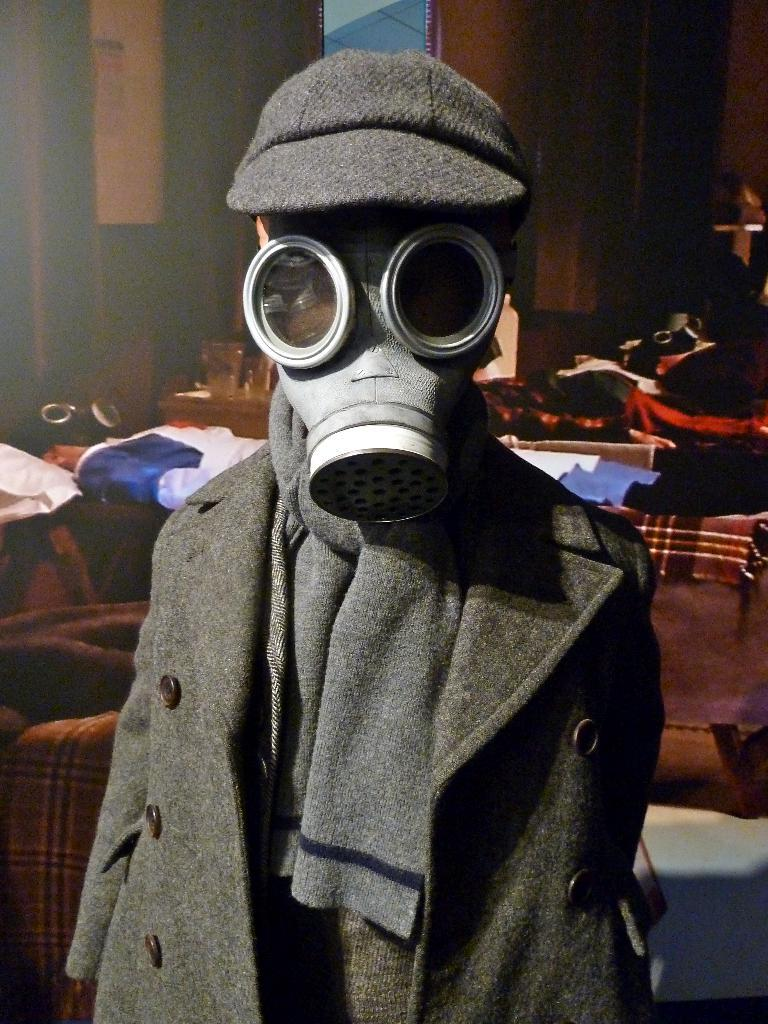What is the main subject of the image? The main subject of the image is a child. What is the child wearing in the image? The child is wearing clothes, a cap, and a face mask. What else can be seen in the image besides the child? There are clothes and objects visible in the image. What type of dress is the laborer wearing in the image? There is no laborer or dress present in the image; it features a child wearing clothes, a cap, and a face mask. What kind of flowers can be seen in the image? There are no flowers visible in the image. 